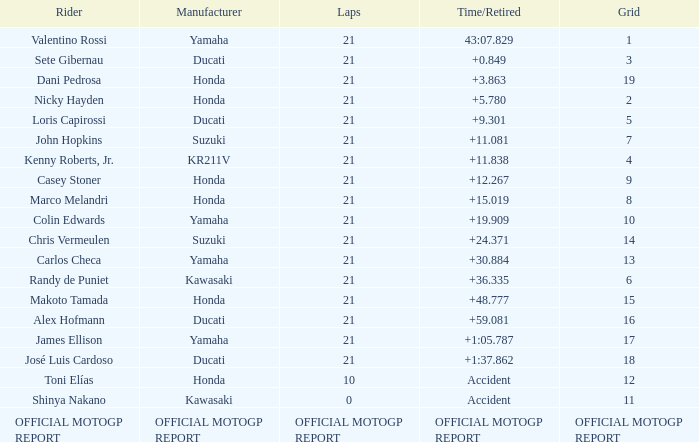When rider John Hopkins had 21 laps, what was the grid? 7.0. 